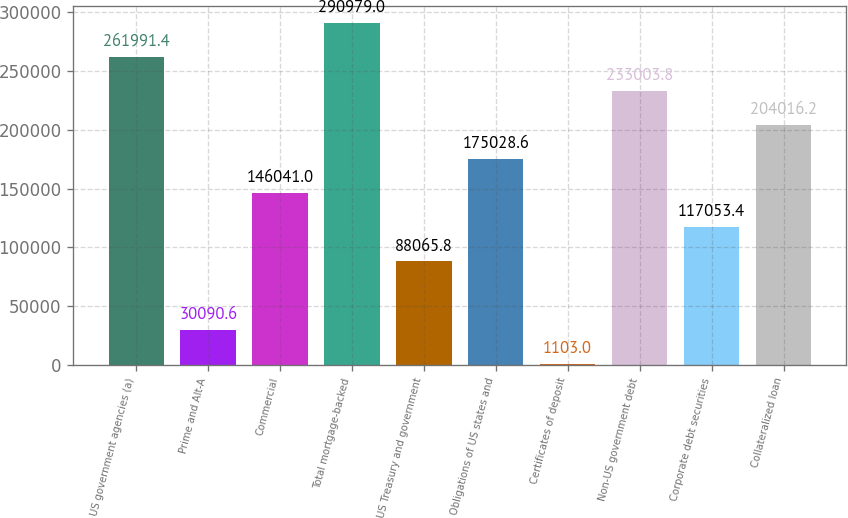<chart> <loc_0><loc_0><loc_500><loc_500><bar_chart><fcel>US government agencies (a)<fcel>Prime and Alt-A<fcel>Commercial<fcel>Total mortgage-backed<fcel>US Treasury and government<fcel>Obligations of US states and<fcel>Certificates of deposit<fcel>Non-US government debt<fcel>Corporate debt securities<fcel>Collateralized loan<nl><fcel>261991<fcel>30090.6<fcel>146041<fcel>290979<fcel>88065.8<fcel>175029<fcel>1103<fcel>233004<fcel>117053<fcel>204016<nl></chart> 